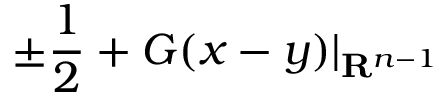Convert formula to latex. <formula><loc_0><loc_0><loc_500><loc_500>\pm { \frac { 1 } { 2 } } + G ( x - y ) | _ { R ^ { n - 1 } }</formula> 